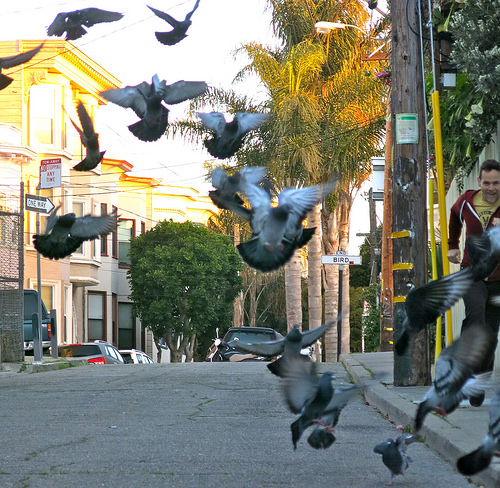<image>
Is there a pigeon above the road? Yes. The pigeon is positioned above the road in the vertical space, higher up in the scene. 